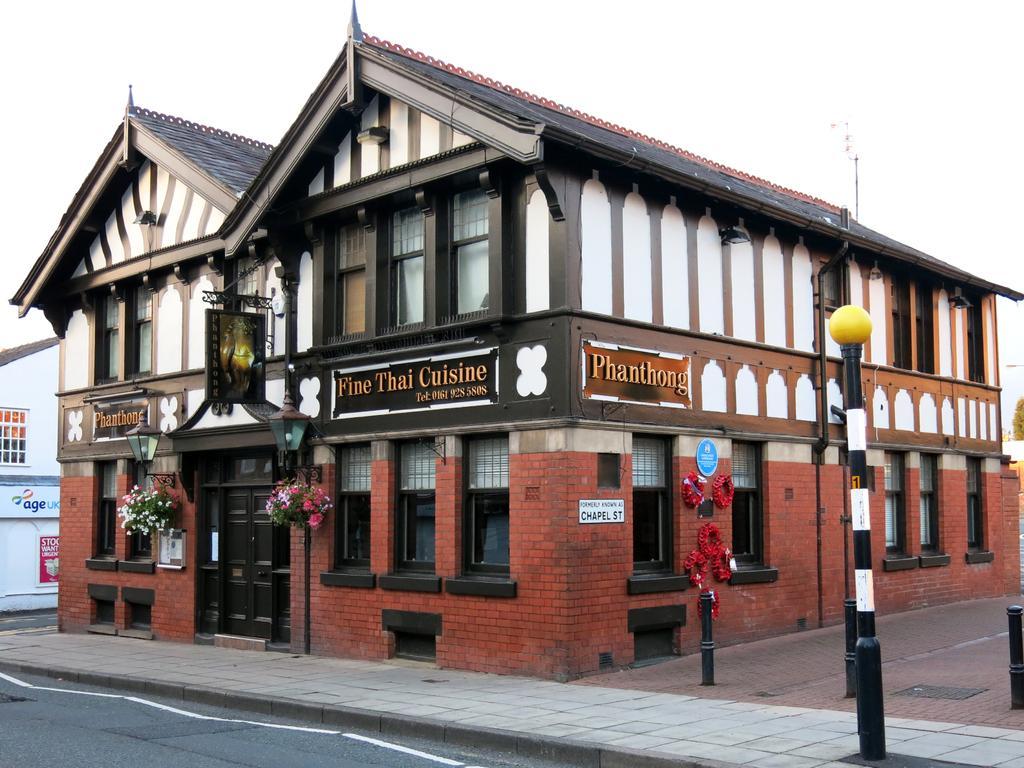Describe this image in one or two sentences. In this picture it looks like a hat shaped restaurant beside the road. It is made of brick walls, windows and a brown door with flower pots, poles & lights in front of it. 